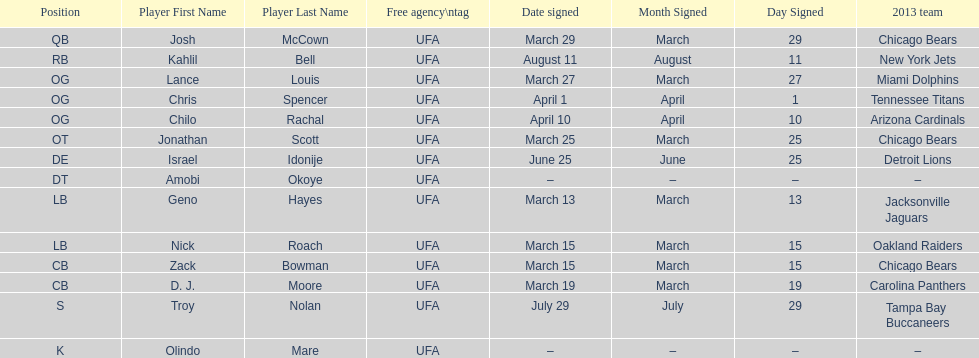His/her first name is the same name as a country. Israel Idonije. 